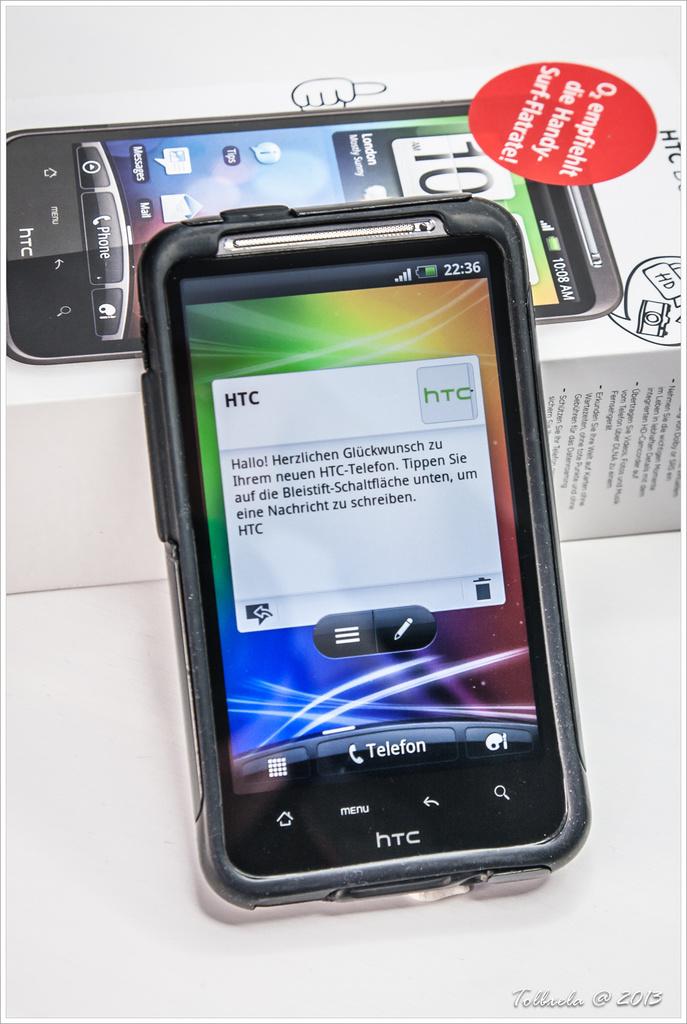What brand of phone is this?
Provide a succinct answer. Htc. Is this a htc phone?
Give a very brief answer. Yes. 